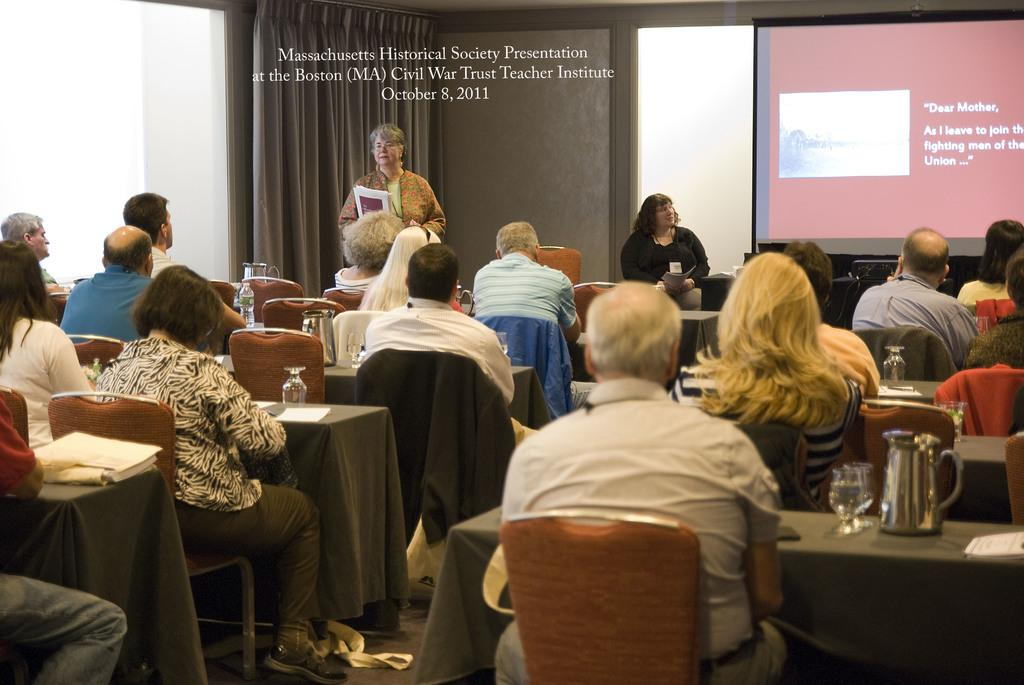What are the people in the image doing? The people in the image are sitting on chairs. What is the surface beneath the chairs? The chairs are on a bag ground. Can you describe the positions of the women in the image? There is a woman standing and a woman sitting in the image. What is the purpose of the screen in the image? The purpose of the screen is not specified in the facts provided. What type of stocking is the woman wearing in the image? There is no information about the woman's clothing, including stockings, in the image. Where is the key located in the image? There is no key present in the image. 